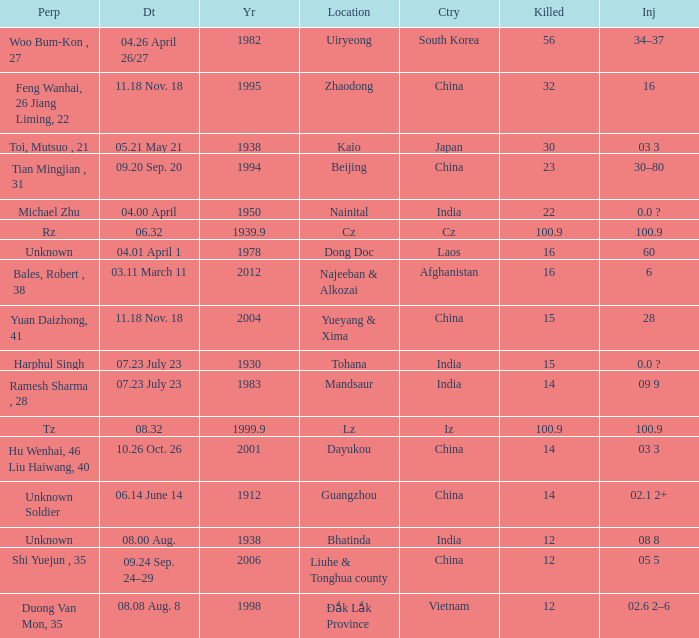What is hurt, when territory is "afghanistan"? 6.0. 